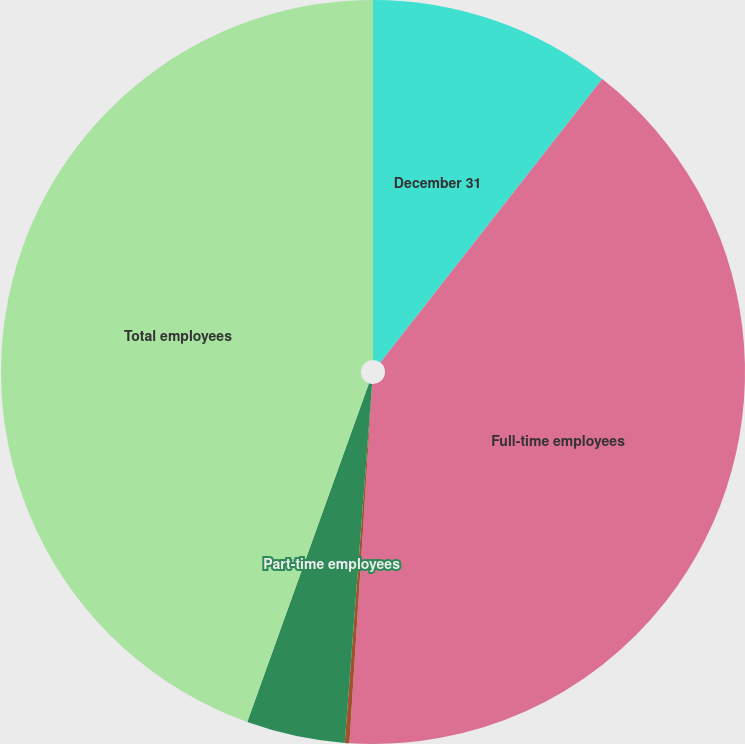Convert chart to OTSL. <chart><loc_0><loc_0><loc_500><loc_500><pie_chart><fcel>December 31<fcel>Full-time employees<fcel>Seasonal employees 2<fcel>Part-time employees<fcel>Total employees<nl><fcel>10.57%<fcel>40.44%<fcel>0.2%<fcel>4.28%<fcel>44.51%<nl></chart> 